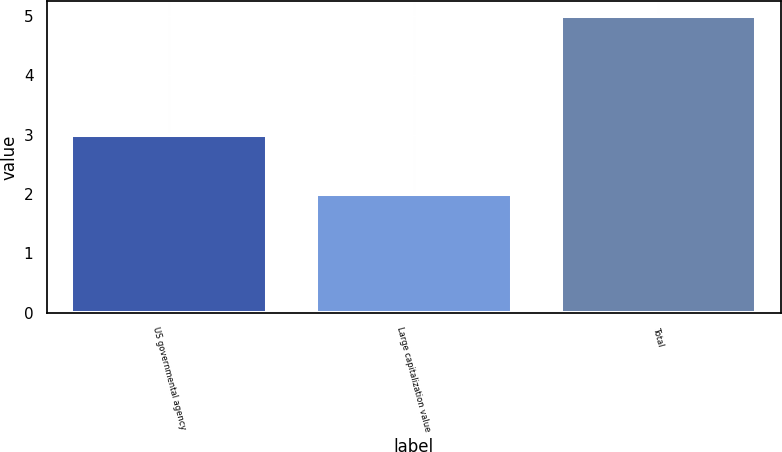Convert chart. <chart><loc_0><loc_0><loc_500><loc_500><bar_chart><fcel>US governmental agency<fcel>Large capitalization value<fcel>Total<nl><fcel>3<fcel>2<fcel>5<nl></chart> 